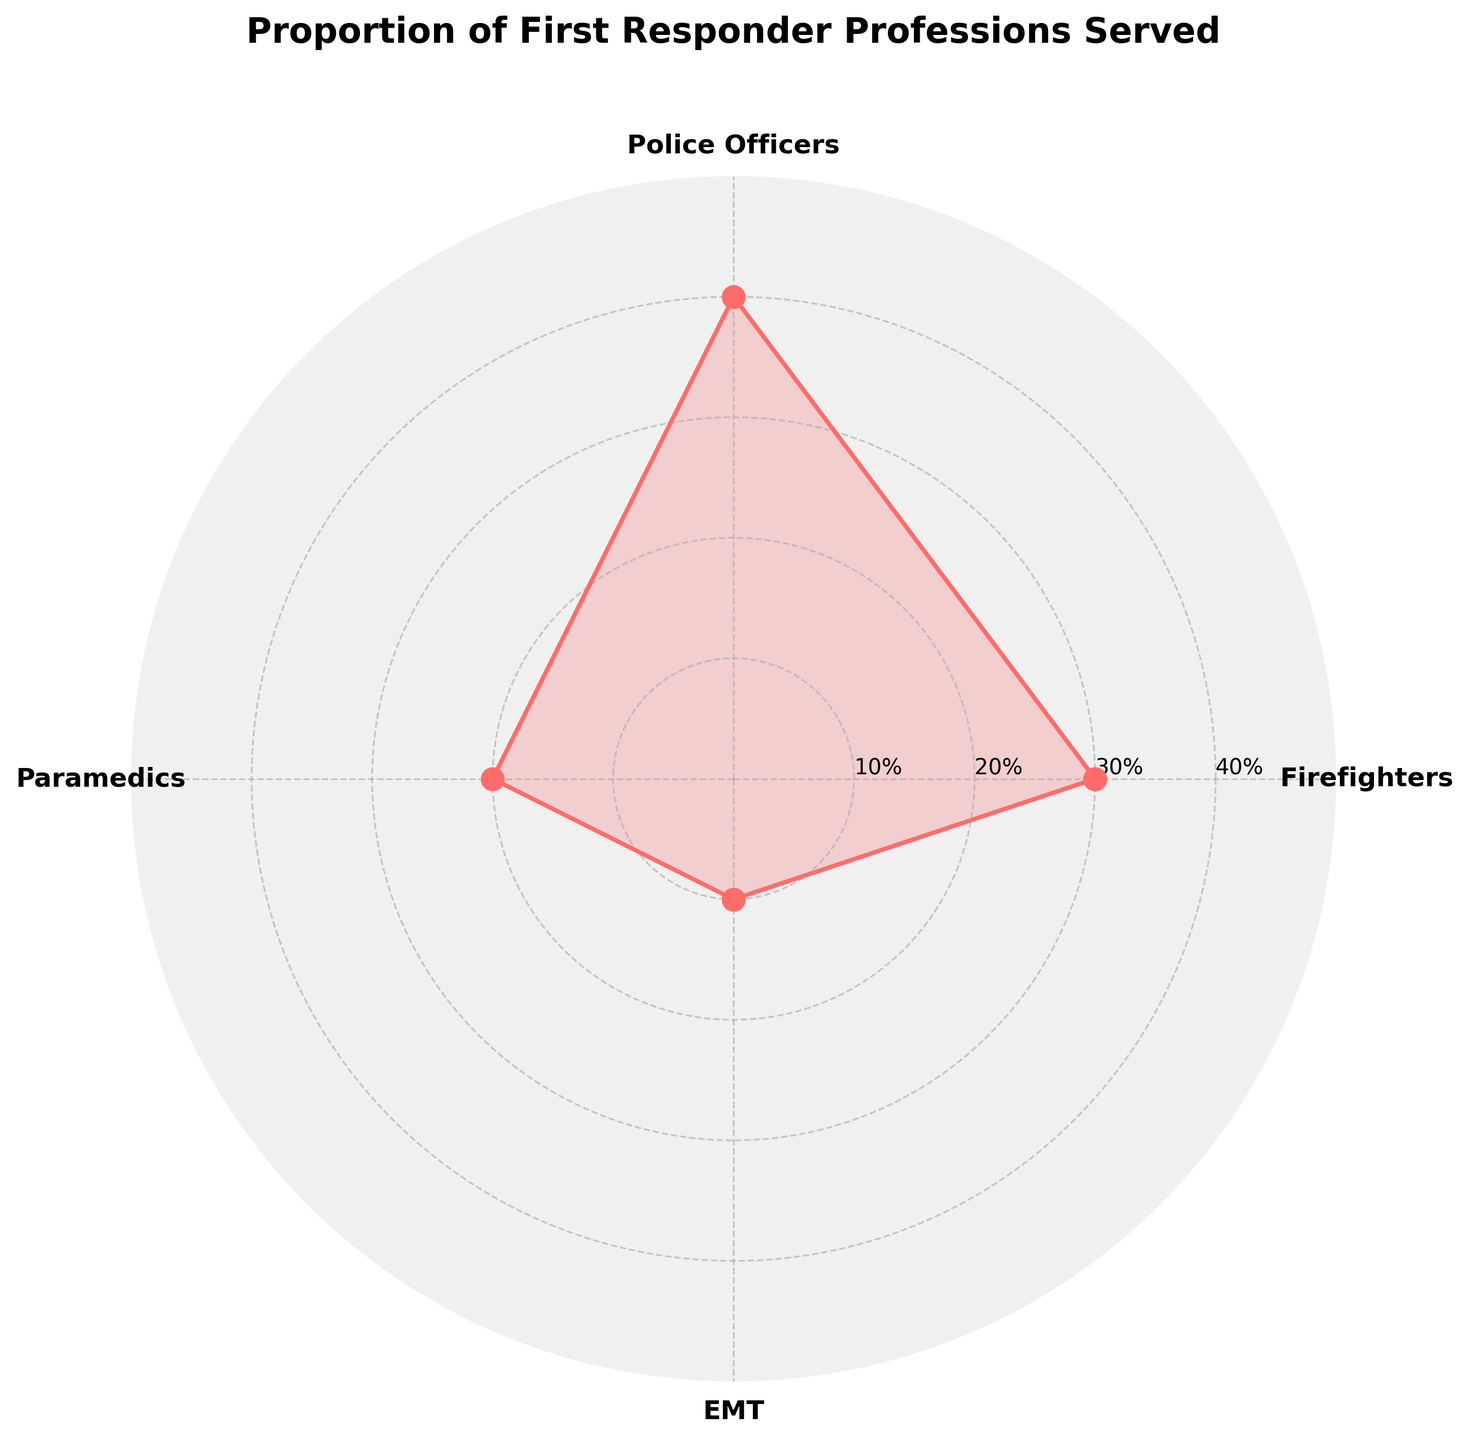what is the title of the plot? The title of the plot is located at the top and is written clearly. It provides a summary of what the plot is about.
Answer: Proportion of First Responder Professions Served Which profession has the highest proportion served? By looking at the plot, you can see which profession corresponds to the largest value on the radial axis.
Answer: Police Officers What is the combined proportion of Firefighters and EMTs served? To find the combined proportion, add the values for Firefighters and EMTs from the plot.
Answer: 40% Which profession has the smallest proportion served? Identify the profession corresponding to the smallest value on the radial axis of the plot.
Answer: EMT How does the proportion of Paramedics compare to the proportion of Firefighters? Compare the values on the radial axis for Paramedics and Firefighters.
Answer: Paramedics have a smaller proportion than Firefighters What is the average proportion of all the professions served? To find the average, sum the proportions of all the professions and divide by the number of professions. (30 + 40 + 20 + 10) / 4 = 25%
Answer: 25% Which two professions combined have a higher proportion than Police Officers? Adding the proportions of different professions and comparing them to the proportion of Police Officers. Firefighters (30%) and Paramedics (20%) combined have 50%, which is higher than Police Officers (40%).
Answer: Firefighters and Paramedics What is the proportion differential between the highest and lowest served professions? Subtract the smallest proportion from the largest proportion. 40% (Police Officers) - 10% (EMT) = 30%
Answer: 30% Is the proportion of firefighters served greater than that of Paramedics and EMTs combined? Compare the proportion of Firefighters to the sum of the proportions of Paramedics and EMTs combined. 30% (Firefighters) < 20% (Paramedics) + 10% (EMTs) = 30%
Answer: No What is the proportion of the profession served that comes right before EMT in the plot? Look at the plot and identify the profession just before EMT in the clockwise direction. That profession’s proportion is Paramedics, which is 20%.
Answer: 20% 